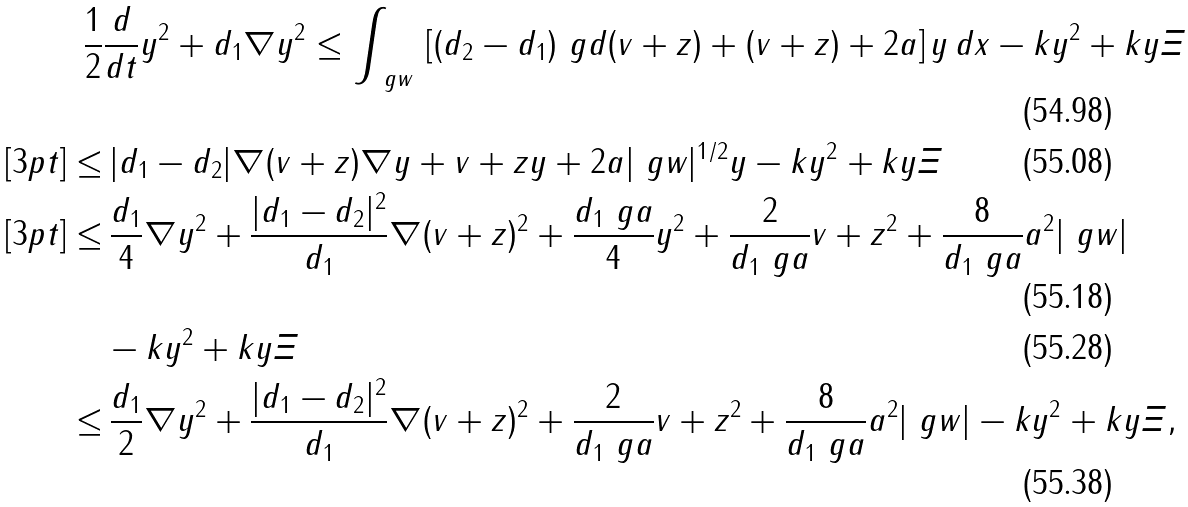Convert formula to latex. <formula><loc_0><loc_0><loc_500><loc_500>\frac { 1 } { 2 } & \frac { d } { d t } \| y \| ^ { 2 } + d _ { 1 } \| \nabla y \| ^ { 2 } \leq \int _ { \ g w } \, \left [ ( d _ { 2 } - d _ { 1 } ) \ g d ( v + z ) + ( v + z ) + 2 a \right ] y \, d x - k \| y \| ^ { 2 } + k \| y \| \| \varXi \| \\ [ 3 p t ] \leq & \, | d _ { 1 } - d _ { 2 } | \| \nabla ( v + z ) \| \| \nabla y \| + \| v + z \| \| y \| + 2 a | \ g w | ^ { 1 / 2 } \| y \| - k \| y \| ^ { 2 } + k \| y \| \| \varXi \| \\ [ 3 p t ] \leq & \, \frac { d _ { 1 } } { 4 } \| \nabla y \| ^ { 2 } + \frac { | d _ { 1 } - d _ { 2 } | ^ { 2 } } { d _ { 1 } } \| \nabla ( v + z ) \| ^ { 2 } + \frac { d _ { 1 } \ g a } { 4 } \| y \| ^ { 2 } + \frac { 2 } { d _ { 1 } \ g a } \| v + z \| ^ { 2 } + \frac { 8 } { d _ { 1 } \ g a } a ^ { 2 } | \ g w | \\ & - k \| y \| ^ { 2 } + k \| y \| \| \varXi \| \\ \leq & \, \frac { d _ { 1 } } { 2 } \| \nabla y \| ^ { 2 } + \frac { | d _ { 1 } - d _ { 2 } | ^ { 2 } } { d _ { 1 } } \| \nabla ( v + z ) \| ^ { 2 } + \frac { 2 } { d _ { 1 } \ g a } \| v + z \| ^ { 2 } + \frac { 8 } { d _ { 1 } \ g a } a ^ { 2 } | \ g w | - k \| y \| ^ { 2 } + k \| y \| \| \varXi \| ,</formula> 